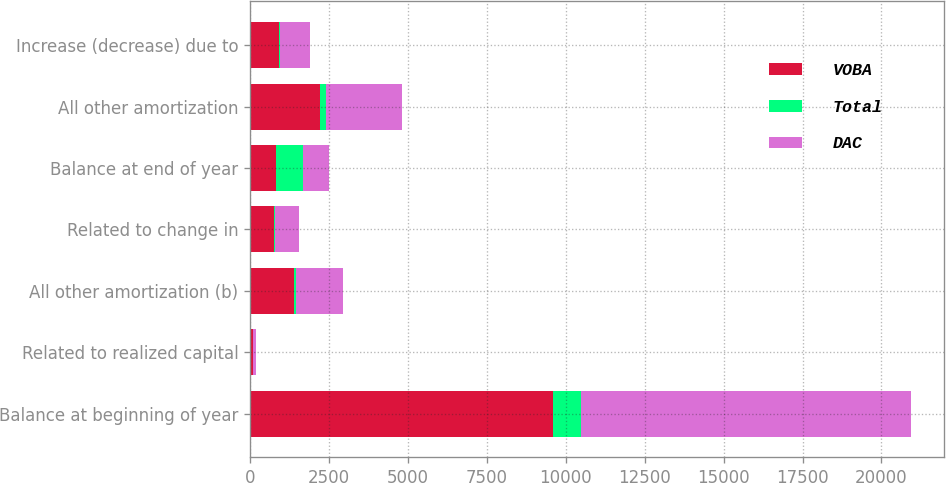<chart> <loc_0><loc_0><loc_500><loc_500><stacked_bar_chart><ecel><fcel>Balance at beginning of year<fcel>Related to realized capital<fcel>All other amortization (b)<fcel>Related to change in<fcel>Balance at end of year<fcel>All other amortization<fcel>Increase (decrease) due to<nl><fcel>VOBA<fcel>9599<fcel>77<fcel>1387<fcel>744<fcel>833<fcel>2214<fcel>904<nl><fcel>Total<fcel>869<fcel>16<fcel>81<fcel>34<fcel>833<fcel>185<fcel>44<nl><fcel>DAC<fcel>10468<fcel>93<fcel>1468<fcel>778<fcel>833<fcel>2399<fcel>948<nl></chart> 